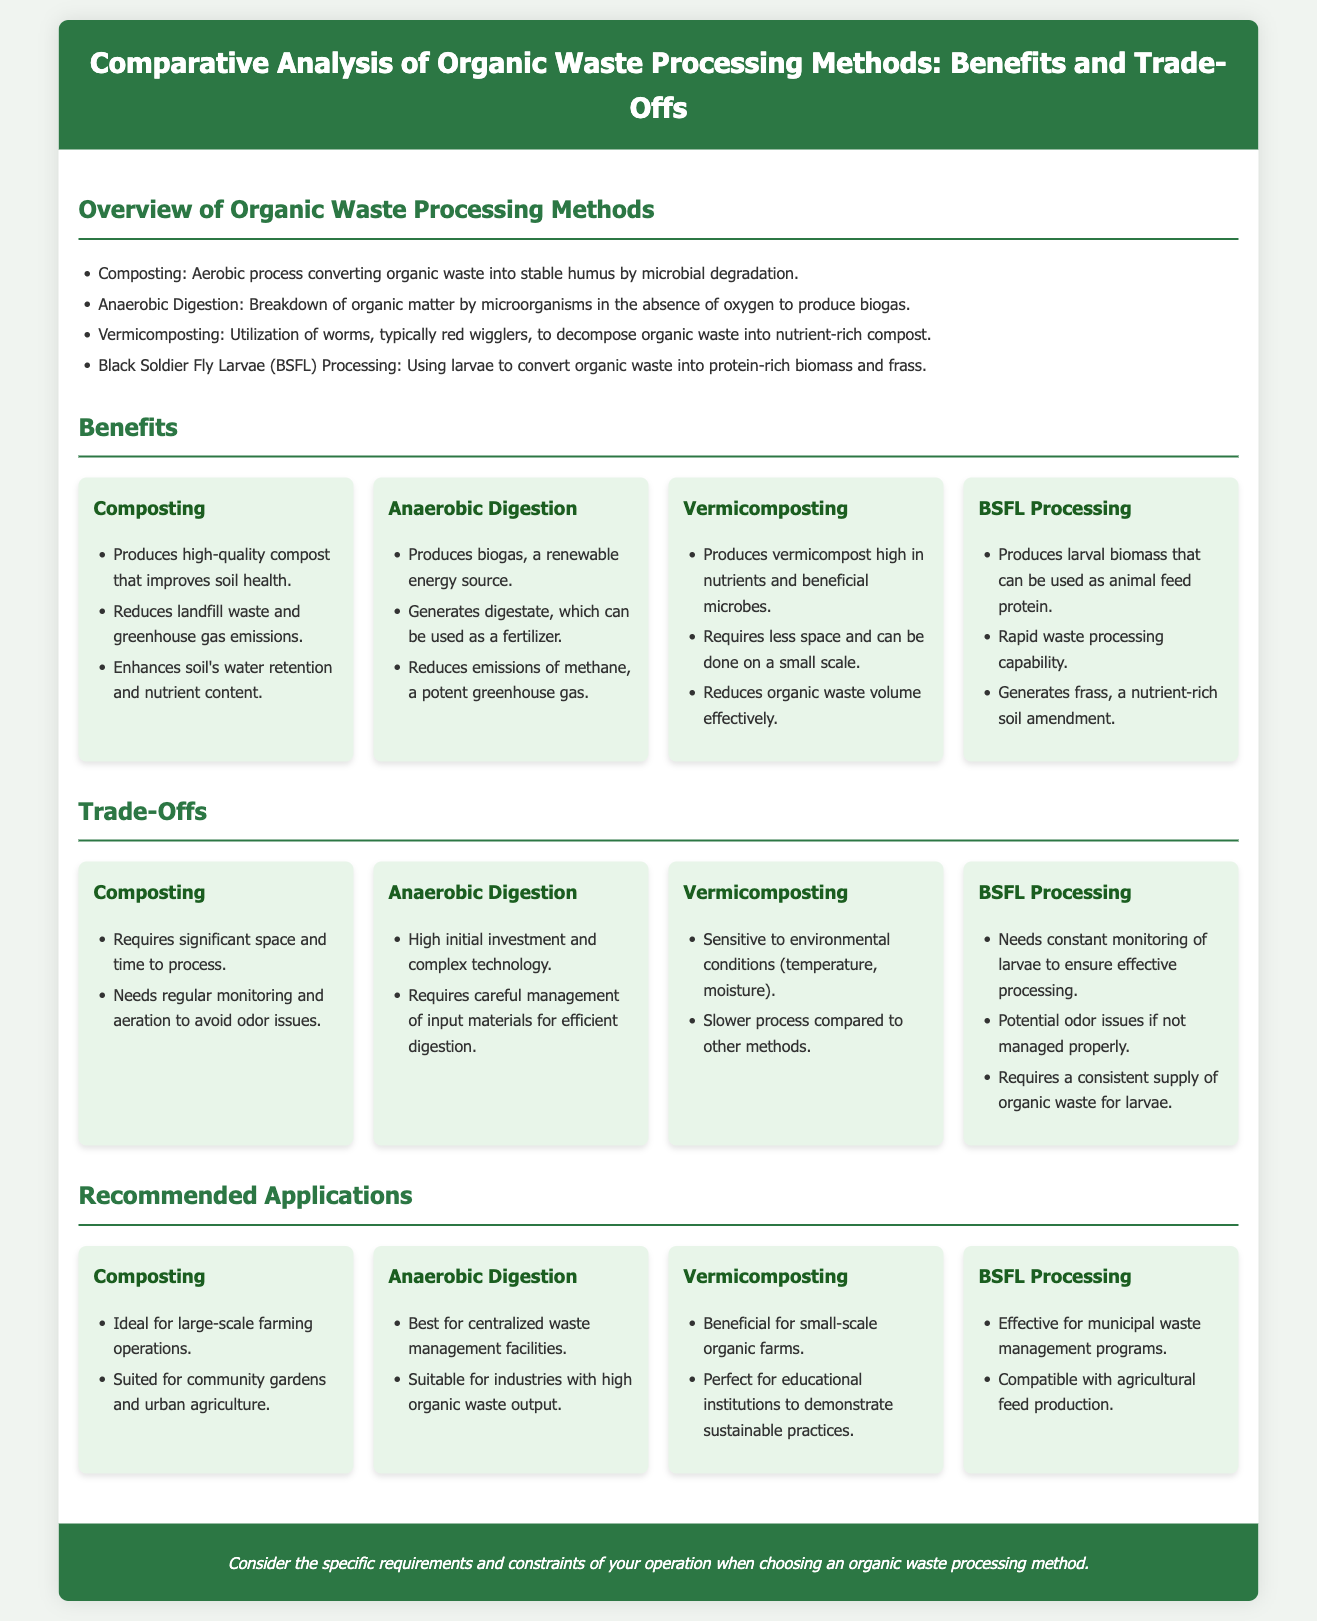What are the four organic waste processing methods mentioned? The document lists composting, anaerobic digestion, vermicomposting, and Black Soldier Fly Larvae processing as the organic waste processing methods.
Answer: composting, anaerobic digestion, vermicomposting, Black Soldier Fly Larvae processing What is a major benefit of composting? The document states that composting produces high-quality compost that improves soil health.
Answer: high-quality compost What is the main output of anaerobic digestion? The document mentions that anaerobic digestion produces biogas, a renewable energy source.
Answer: biogas What is a trade-off of vermicomposting? According to the document, vermicomposting is sensitive to environmental conditions like temperature and moisture.
Answer: sensitive to environmental conditions Which method is ideal for small-scale organic farms? The document suggests vermicomposting as beneficial for small-scale organic farms.
Answer: vermicomposting What renewable resource is generated from anaerobic digestion? The document specifies that biogas is a renewable energy source produced by anaerobic digestion.
Answer: biogas Which organic waste processing method requires careful management of input materials? The document indicates that anaerobic digestion requires careful management of input materials for efficient digestion.
Answer: anaerobic digestion What does BSFL processing generate as a nutrient-rich soil amendment? The document states that BSFL processing generates frass as a nutrient-rich soil amendment.
Answer: frass Where is composting recommended to be utilized? The document recommends composting for large-scale farming operations and community gardens.
Answer: large-scale farming operations, community gardens 